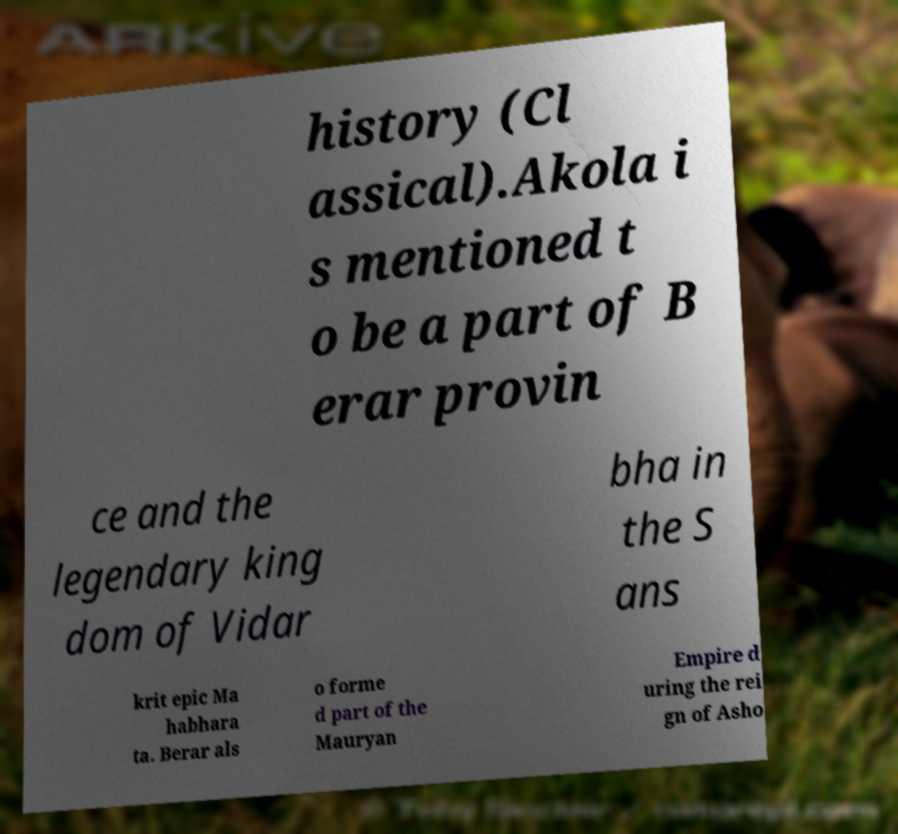For documentation purposes, I need the text within this image transcribed. Could you provide that? history (Cl assical).Akola i s mentioned t o be a part of B erar provin ce and the legendary king dom of Vidar bha in the S ans krit epic Ma habhara ta. Berar als o forme d part of the Mauryan Empire d uring the rei gn of Asho 